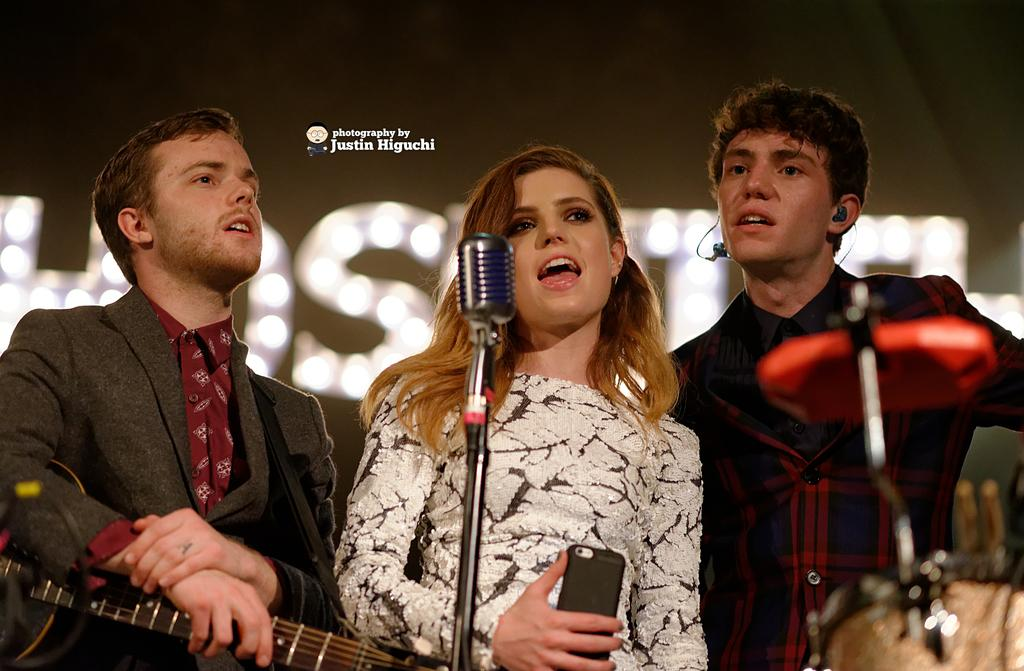How many people are in the image? There are three persons in the image. What are the persons doing in the image? The persons are standing in front of a microphone. Which person is using the microphone? One person is singing on the microphone. What instrument is being held by one of the persons? Another person is holding a guitar. Can you see a boat in the background of the image? There is no boat present in the image. What type of boundary is visible in the image? There is no boundary visible in the image. 